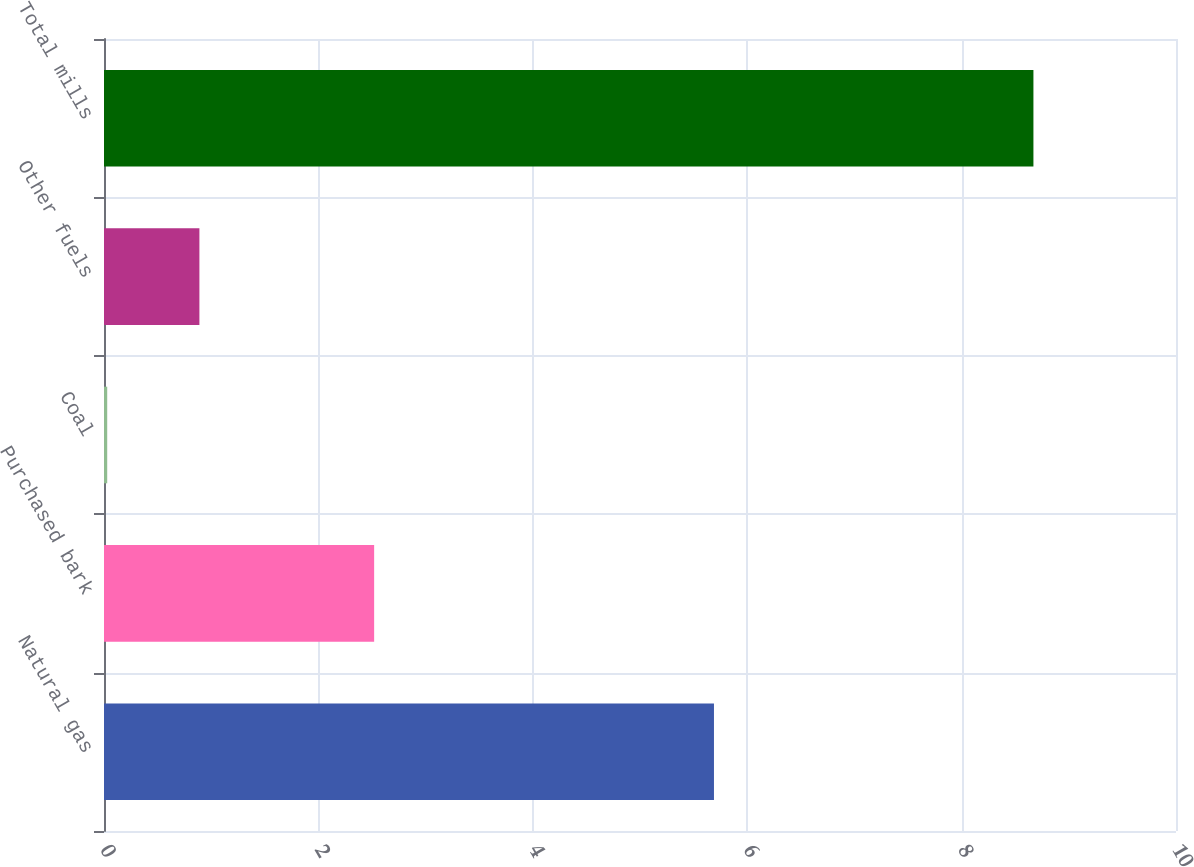Convert chart to OTSL. <chart><loc_0><loc_0><loc_500><loc_500><bar_chart><fcel>Natural gas<fcel>Purchased bark<fcel>Coal<fcel>Other fuels<fcel>Total mills<nl><fcel>5.69<fcel>2.52<fcel>0.03<fcel>0.89<fcel>8.67<nl></chart> 